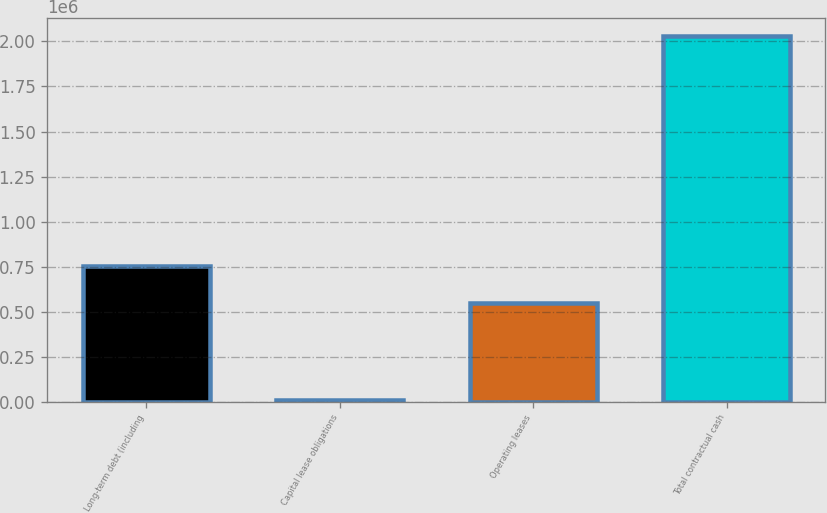Convert chart to OTSL. <chart><loc_0><loc_0><loc_500><loc_500><bar_chart><fcel>Long-term debt (including<fcel>Capital lease obligations<fcel>Operating leases<fcel>Total contractual cash<nl><fcel>750535<fcel>8194<fcel>548364<fcel>2.0299e+06<nl></chart> 